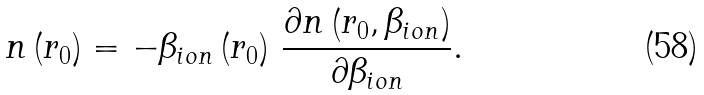<formula> <loc_0><loc_0><loc_500><loc_500>n \left ( r _ { 0 } \right ) = - \beta _ { i o n } \left ( r _ { 0 } \right ) \, \frac { \partial n \left ( r _ { 0 } , \beta _ { i o n } \right ) } { \partial \beta _ { i o n } } .</formula> 